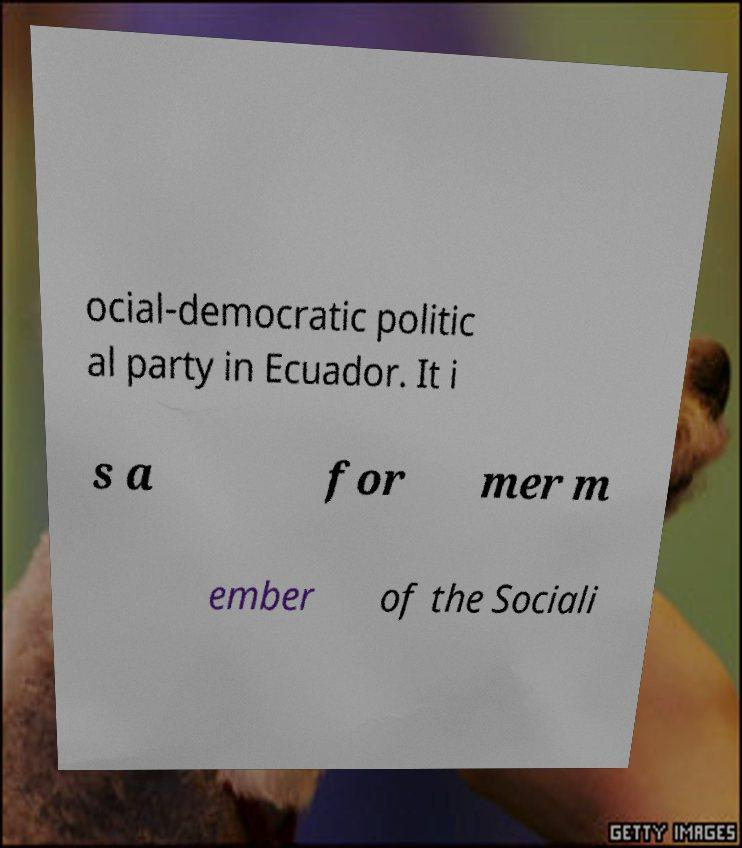Please identify and transcribe the text found in this image. ocial-democratic politic al party in Ecuador. It i s a for mer m ember of the Sociali 